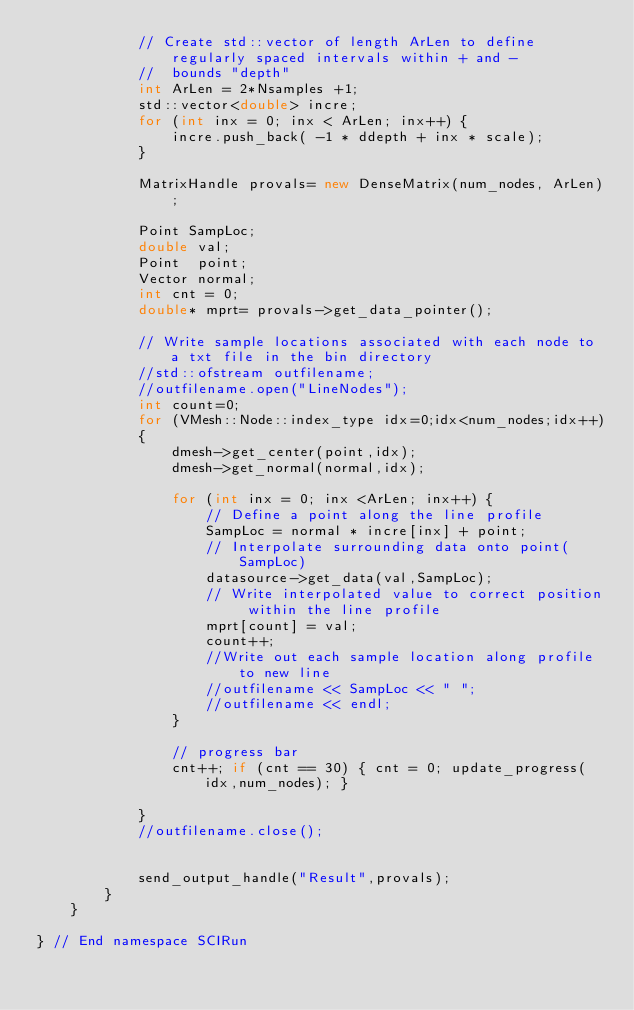Convert code to text. <code><loc_0><loc_0><loc_500><loc_500><_C++_>			// Create std::vector of length ArLen to define regularly spaced intervals within + and - 
			//	bounds "depth"
			int ArLen = 2*Nsamples +1;
			std::vector<double> incre;
			for (int inx = 0; inx < ArLen; inx++) {
				incre.push_back( -1 * ddepth + inx * scale);
			}
			
			MatrixHandle provals= new DenseMatrix(num_nodes, ArLen);
					
			Point SampLoc;
			double val;
			Point  point;
			Vector normal;
			int cnt = 0;
			double* mprt= provals->get_data_pointer();

			// Write sample locations associated with each node to a txt file in the bin directory
			//std::ofstream outfilename;
			//outfilename.open("LineNodes");
			int count=0;
			for (VMesh::Node::index_type idx=0;idx<num_nodes;idx++)
			{
				dmesh->get_center(point,idx);
				dmesh->get_normal(normal,idx);
				
				for (int inx = 0; inx <ArLen; inx++) {
					// Define a point along the line profile
					SampLoc = normal * incre[inx] + point;
					// Interpolate surrounding data onto point(SampLoc)
					datasource->get_data(val,SampLoc);
					// Write interpolated value to correct position within the line profile
					mprt[count] = val;
					count++;
					//Write out each sample location along profile to new line
					//outfilename << SampLoc << " ";
					//outfilename << endl;
				}
				
				// progress bar
				cnt++; if (cnt == 30) { cnt = 0; update_progress(idx,num_nodes); }
				
			}
			//outfilename.close();
			
			
			send_output_handle("Result",provals);
		}
	}
	
} // End namespace SCIRun


</code> 